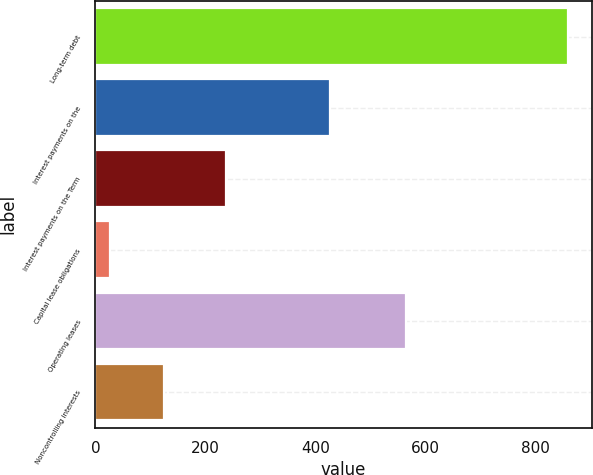<chart> <loc_0><loc_0><loc_500><loc_500><bar_chart><fcel>Long-term debt<fcel>Interest payments on the<fcel>Interest payments on the Term<fcel>Capital lease obligations<fcel>Operating leases<fcel>Noncontrolling interests<nl><fcel>860<fcel>426<fcel>238<fcel>26<fcel>565<fcel>125<nl></chart> 